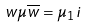Convert formula to latex. <formula><loc_0><loc_0><loc_500><loc_500>w \mu \overline { w } = \mu _ { 1 } { i }</formula> 